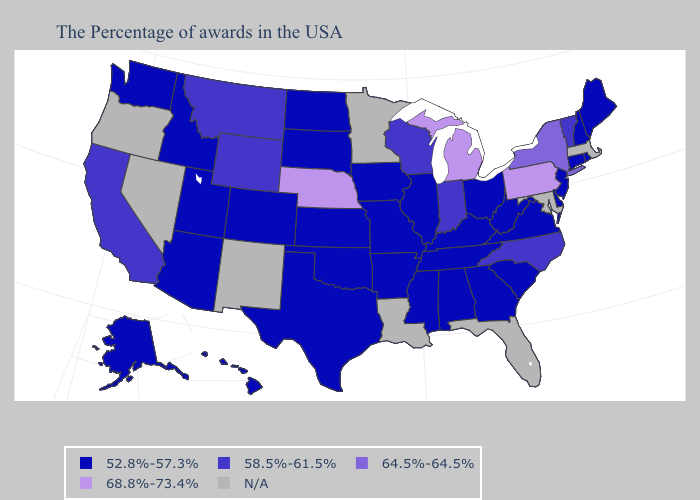Among the states that border Florida , which have the highest value?
Answer briefly. Georgia, Alabama. Name the states that have a value in the range N/A?
Keep it brief. Massachusetts, Maryland, Florida, Louisiana, Minnesota, New Mexico, Nevada, Oregon. Name the states that have a value in the range 52.8%-57.3%?
Short answer required. Maine, Rhode Island, New Hampshire, Connecticut, New Jersey, Delaware, Virginia, South Carolina, West Virginia, Ohio, Georgia, Kentucky, Alabama, Tennessee, Illinois, Mississippi, Missouri, Arkansas, Iowa, Kansas, Oklahoma, Texas, South Dakota, North Dakota, Colorado, Utah, Arizona, Idaho, Washington, Alaska, Hawaii. What is the value of Idaho?
Be succinct. 52.8%-57.3%. Name the states that have a value in the range 58.5%-61.5%?
Quick response, please. Vermont, North Carolina, Indiana, Wisconsin, Wyoming, Montana, California. Among the states that border Michigan , does Ohio have the highest value?
Short answer required. No. What is the value of Alabama?
Short answer required. 52.8%-57.3%. Which states have the lowest value in the USA?
Keep it brief. Maine, Rhode Island, New Hampshire, Connecticut, New Jersey, Delaware, Virginia, South Carolina, West Virginia, Ohio, Georgia, Kentucky, Alabama, Tennessee, Illinois, Mississippi, Missouri, Arkansas, Iowa, Kansas, Oklahoma, Texas, South Dakota, North Dakota, Colorado, Utah, Arizona, Idaho, Washington, Alaska, Hawaii. Does Pennsylvania have the highest value in the Northeast?
Write a very short answer. Yes. What is the value of Illinois?
Write a very short answer. 52.8%-57.3%. Name the states that have a value in the range 64.5%-64.5%?
Answer briefly. New York. What is the lowest value in the USA?
Keep it brief. 52.8%-57.3%. What is the highest value in states that border Kentucky?
Be succinct. 58.5%-61.5%. What is the lowest value in the USA?
Concise answer only. 52.8%-57.3%. 